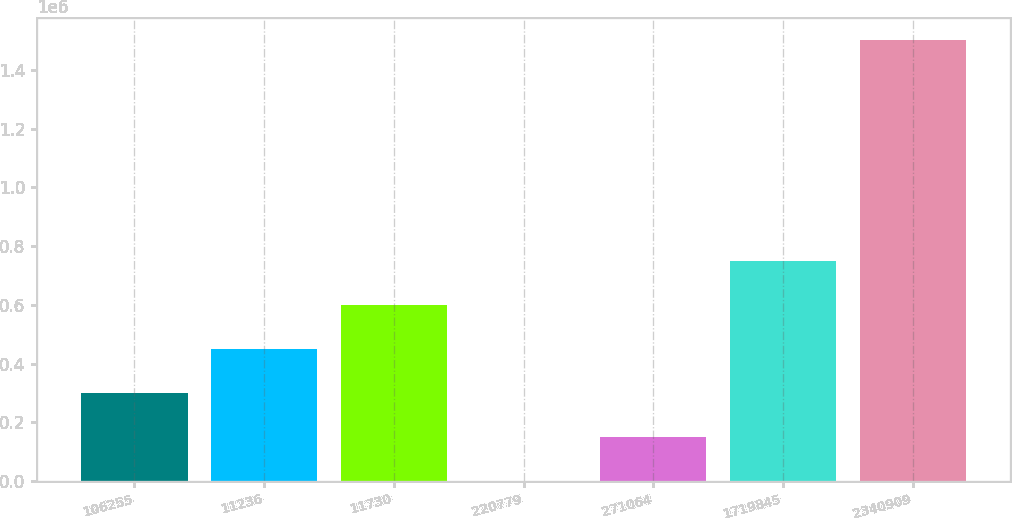Convert chart to OTSL. <chart><loc_0><loc_0><loc_500><loc_500><bar_chart><fcel>106255<fcel>11236<fcel>11730<fcel>220779<fcel>271064<fcel>1719845<fcel>2340909<nl><fcel>300135<fcel>450187<fcel>600239<fcel>31<fcel>150083<fcel>750292<fcel>1.50055e+06<nl></chart> 